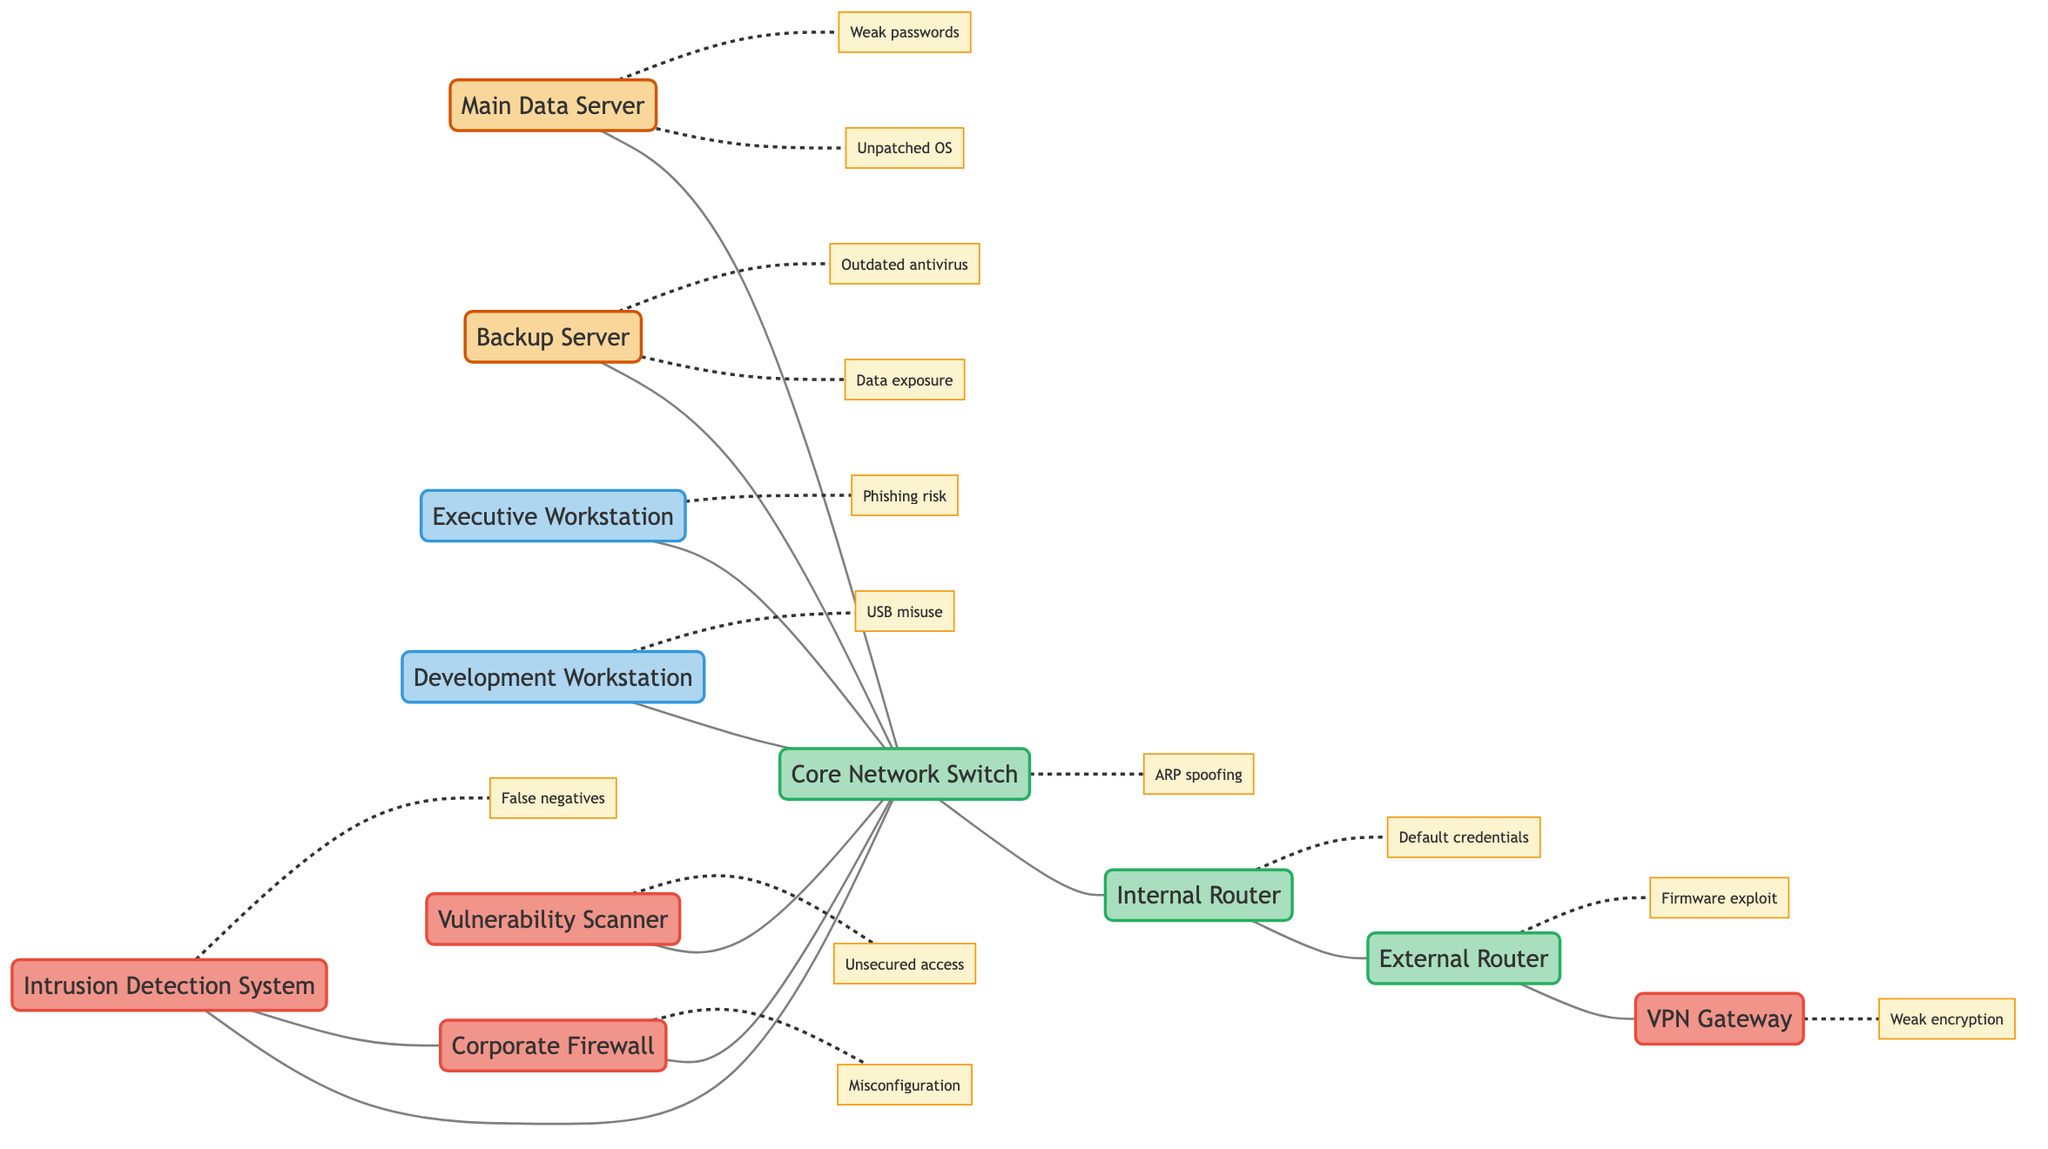What is the total number of nodes in the diagram? The diagram contains nodes for the Main Data Server, Backup Server, Executive Workstation, Development Workstation, Corporate Firewall, Internal Router, External Router, Core Network Switch, VPN Gateway, Vulnerability Scanner, and Intrusion Detection System. Counting these gives a total of 11 nodes.
Answer: 11 How many edges are there connecting the nodes? Each edge represents a connection between two nodes. In the diagram, the connections are counted as follows: Main Data Server to Core Network Switch, Backup Server to Core Network Switch, Executive Workstation to Core Network Switch, Development Workstation to Core Network Switch, Corporate Firewall to Core Network Switch, Core Network Switch to Internal Router, Internal Router to External Router, External Router to VPN Gateway, Vulnerability Scanner to Core Network Switch, Intrusion Detection System to Core Network Switch, and Intrusion Detection System to Corporate Firewall. Counting these connections gives a total of 10 edges.
Answer: 10 Which nodes connect directly to the Core Network Switch? The Core Network Switch connects to the Main Data Server, Backup Server, Executive Workstation, Development Workstation, Corporate Firewall, Vulnerability Scanner, and Intrusion Detection System. Listing these gives: Main Data Server, Backup Server, Executive Workstation, Development Workstation, Corporate Firewall, Vulnerability Scanner, Intrusion Detection System.
Answer: Main Data Server, Backup Server, Executive Workstation, Development Workstation, Corporate Firewall, Vulnerability Scanner, Intrusion Detection System What are the vulnerabilities associated with the Corporate Firewall? The Corporate Firewall is listed with vulnerabilities for misconfiguration and outdated firmware. These two are the specific vulnerabilities noted for this node that need attention.
Answer: Misconfiguration, outdated firmware Which nodes are connected to the External Router? The External Router connects to the Internal Router and the VPN Gateway. By observing the diagram, we can see that it has these two direct connections.
Answer: Internal Router, VPN Gateway Which workstation has the highest number of listed vulnerabilities? Comparing the vulnerabilities listed for both workstations: Executive Workstation has two vulnerabilities—phishing risk and malware infection. The Development Workstation also has two vulnerabilities—USB port misuse and insufficient privilege separation. However, both have an equal number of vulnerabilities, but the Executive Workstation is noted first in the query. Therefore, the Executive Workstation is taken as the answer.
Answer: Executive Workstation What is the relationship between the Intrusion Detection System and the Corporate Firewall? The Intrusion Detection System directly connects to the Core Network Switch and also has a direct connection to the Corporate Firewall. Therefore, their relationship can be defined as the Intrusion Detection System monitoring or interacting with the Corporate Firewall for security checks.
Answer: Direct connection How many different types of vulnerabilities are found across all nodes? By examining the vulnerabilities listed for all nodes, we identify: unpatched OS vulnerability, weak password policy, backup data exposure, outdated antivirus, phishing risk, malware infection, USB port misuse, insufficient privilege separation, misconfiguration, default credentials, firmware exploit, ARP spoofing, MAC flooding, weak encryption, credential reuse vulnerabilities, unsecured access, false negatives, and evasion techniques. Counting these reveals a total of 17 unique vulnerabilities across the nodes.
Answer: 17 